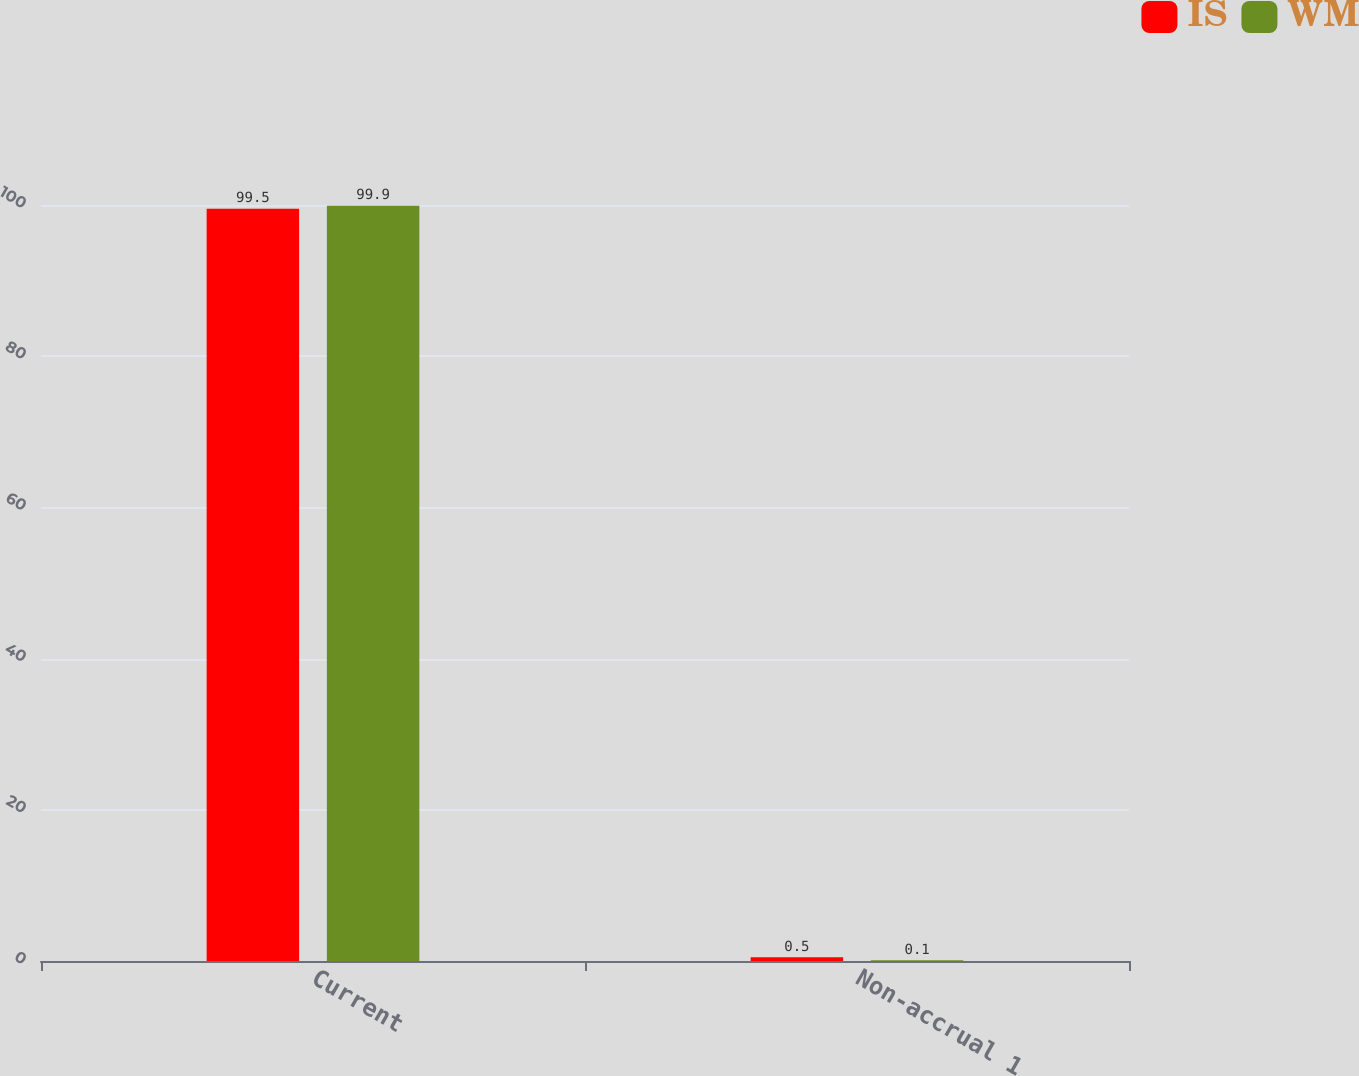Convert chart to OTSL. <chart><loc_0><loc_0><loc_500><loc_500><stacked_bar_chart><ecel><fcel>Current<fcel>Non-accrual 1<nl><fcel>IS<fcel>99.5<fcel>0.5<nl><fcel>WM<fcel>99.9<fcel>0.1<nl></chart> 